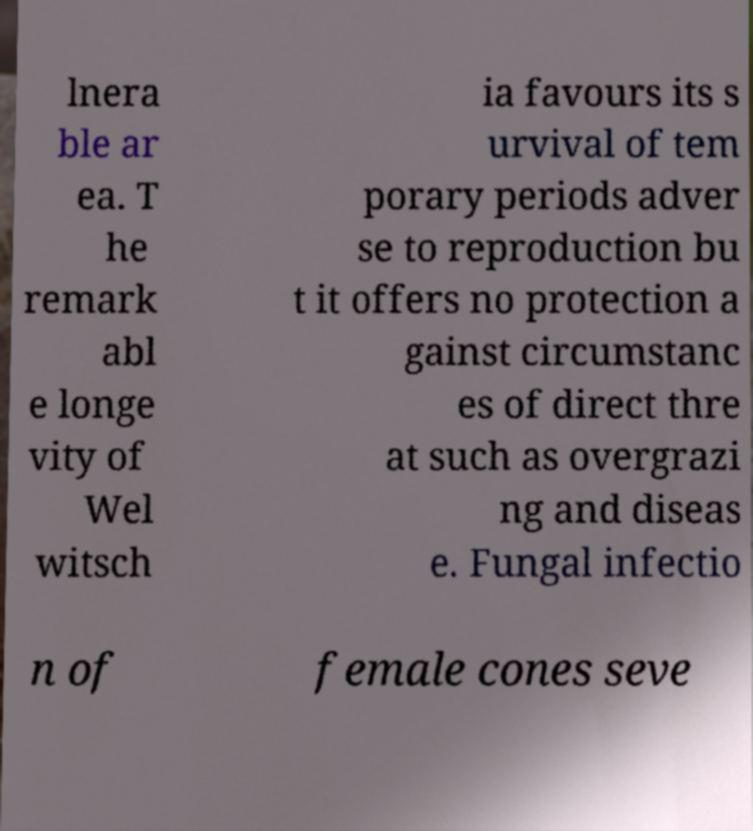Can you accurately transcribe the text from the provided image for me? lnera ble ar ea. T he remark abl e longe vity of Wel witsch ia favours its s urvival of tem porary periods adver se to reproduction bu t it offers no protection a gainst circumstanc es of direct thre at such as overgrazi ng and diseas e. Fungal infectio n of female cones seve 